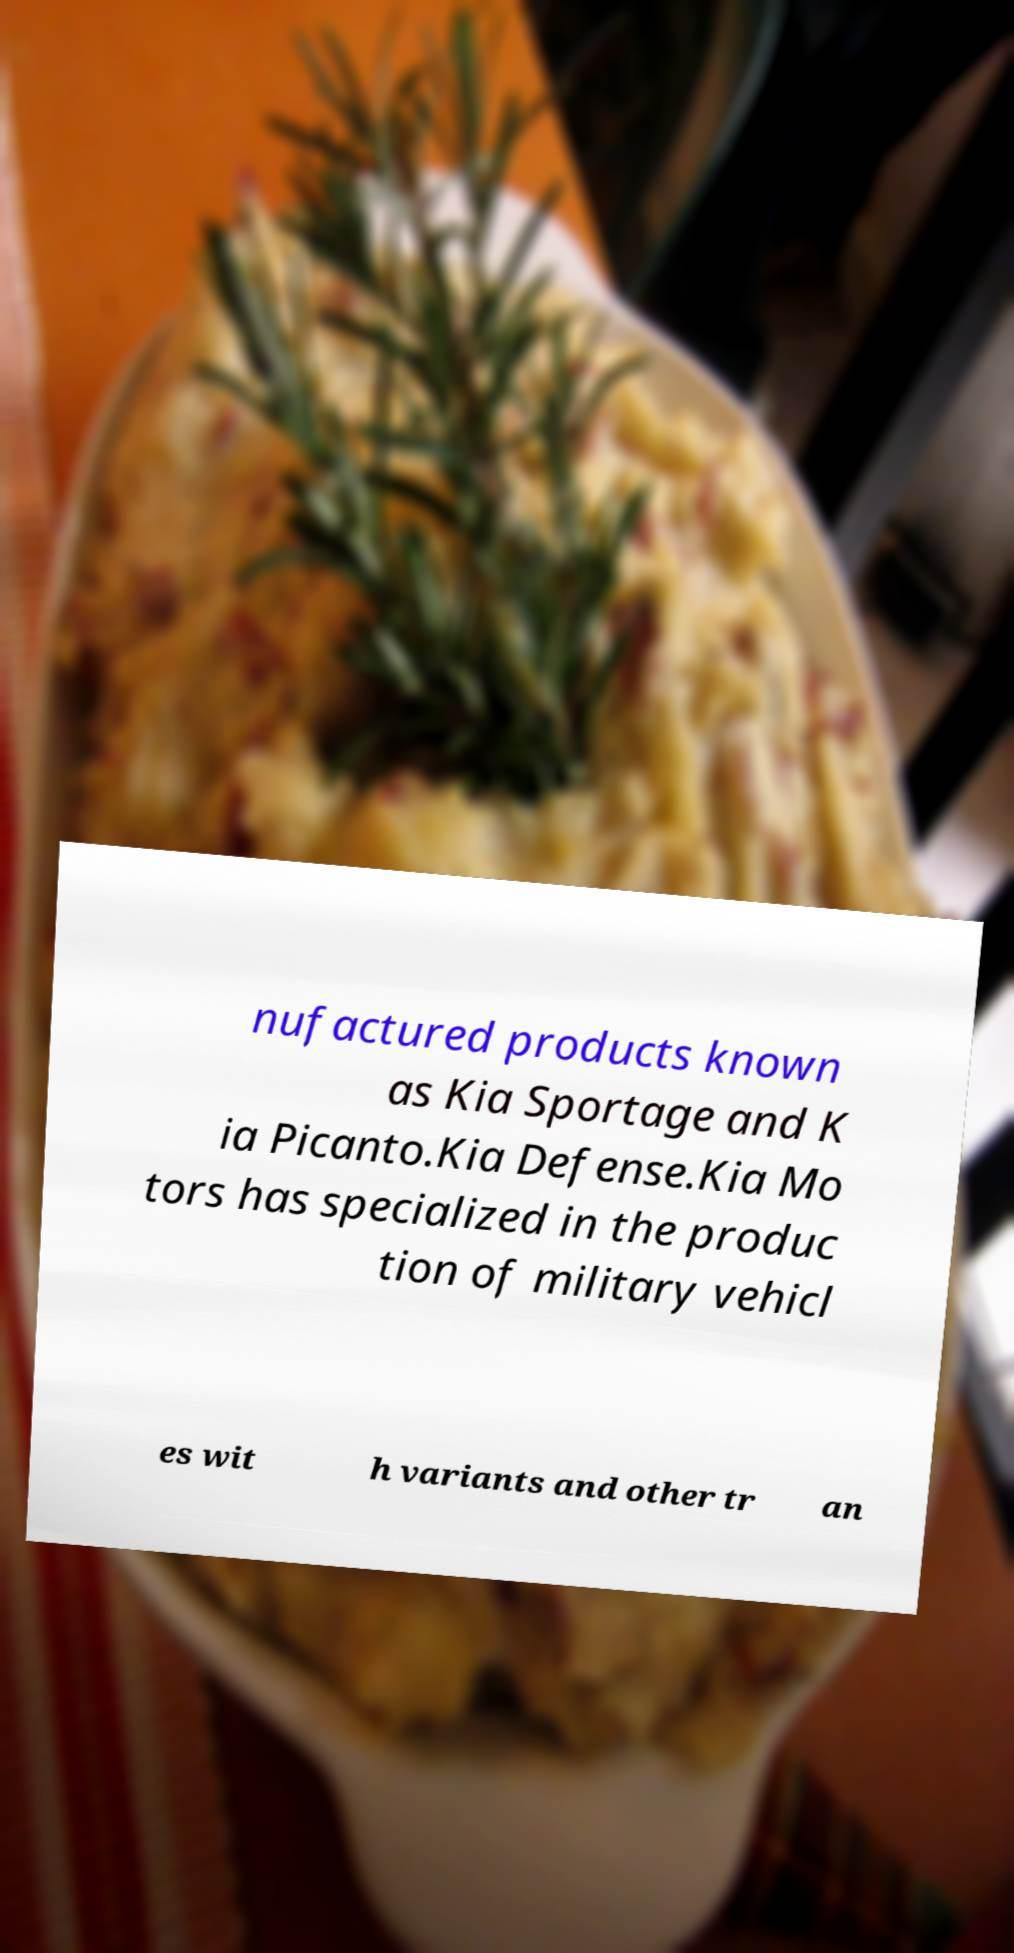Could you assist in decoding the text presented in this image and type it out clearly? nufactured products known as Kia Sportage and K ia Picanto.Kia Defense.Kia Mo tors has specialized in the produc tion of military vehicl es wit h variants and other tr an 